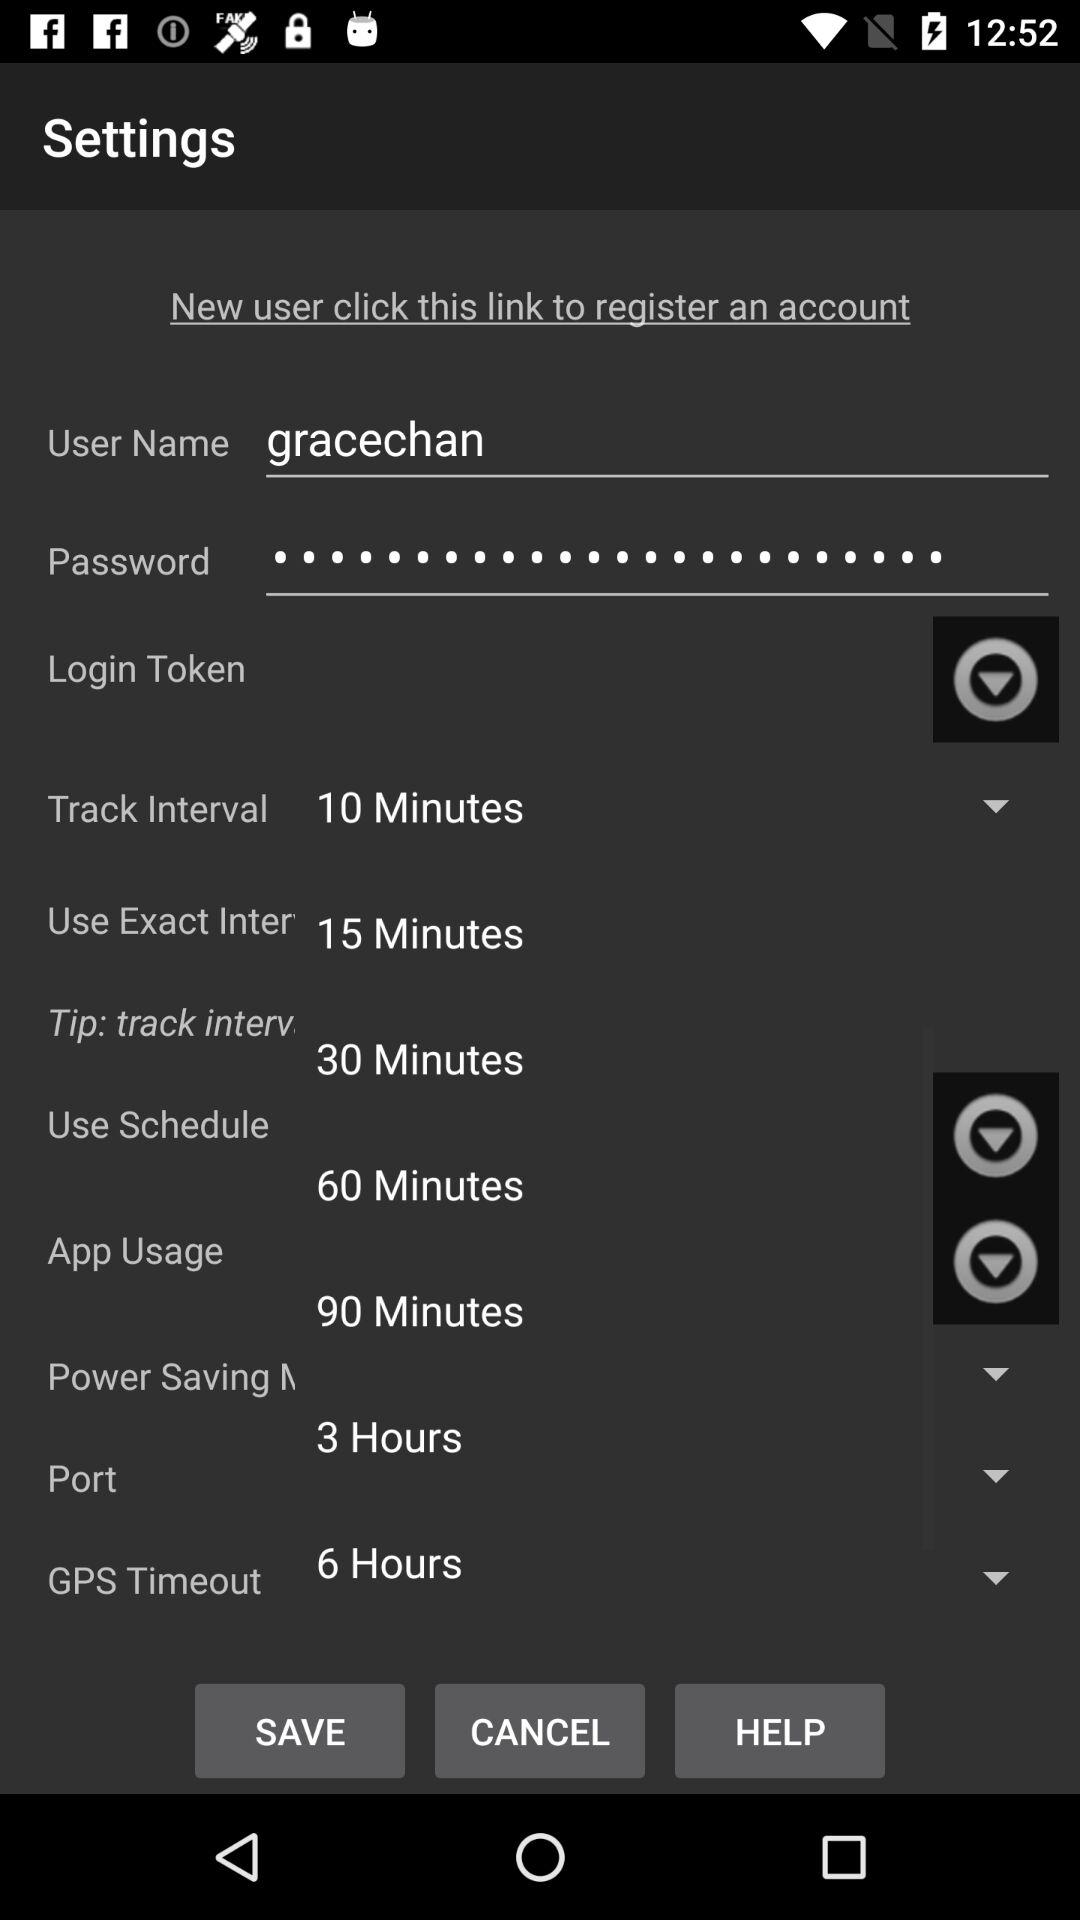What is the setting of GPS timeout?
When the provided information is insufficient, respond with <no answer>. <no answer> 